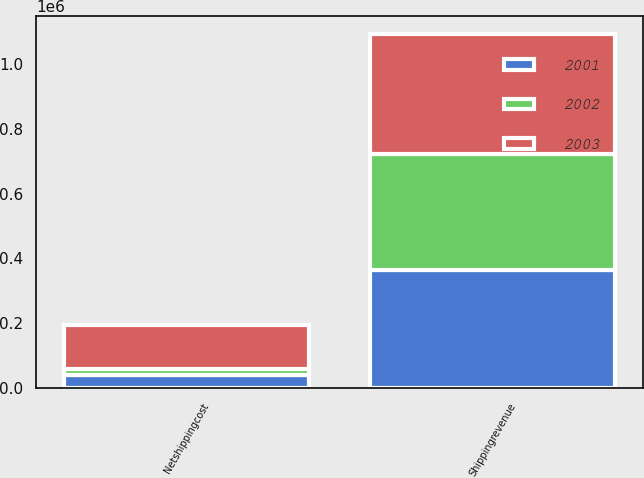Convert chart to OTSL. <chart><loc_0><loc_0><loc_500><loc_500><stacked_bar_chart><ecel><fcel>Shippingrevenue<fcel>Netshippingcost<nl><fcel>2003<fcel>372000<fcel>136468<nl><fcel>2001<fcel>364749<fcel>39554<nl><fcel>2002<fcel>357325<fcel>19163<nl></chart> 